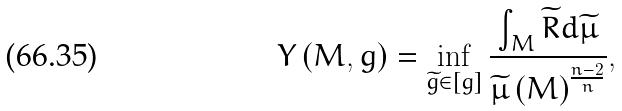Convert formula to latex. <formula><loc_0><loc_0><loc_500><loc_500>Y \left ( M , g \right ) = \inf _ { \widetilde { g } \in \left [ g \right ] } \frac { \int _ { M } \widetilde { R } d \widetilde { \mu } } { \widetilde { \mu } \left ( M \right ) ^ { \frac { n - 2 } { n } } } ,</formula> 